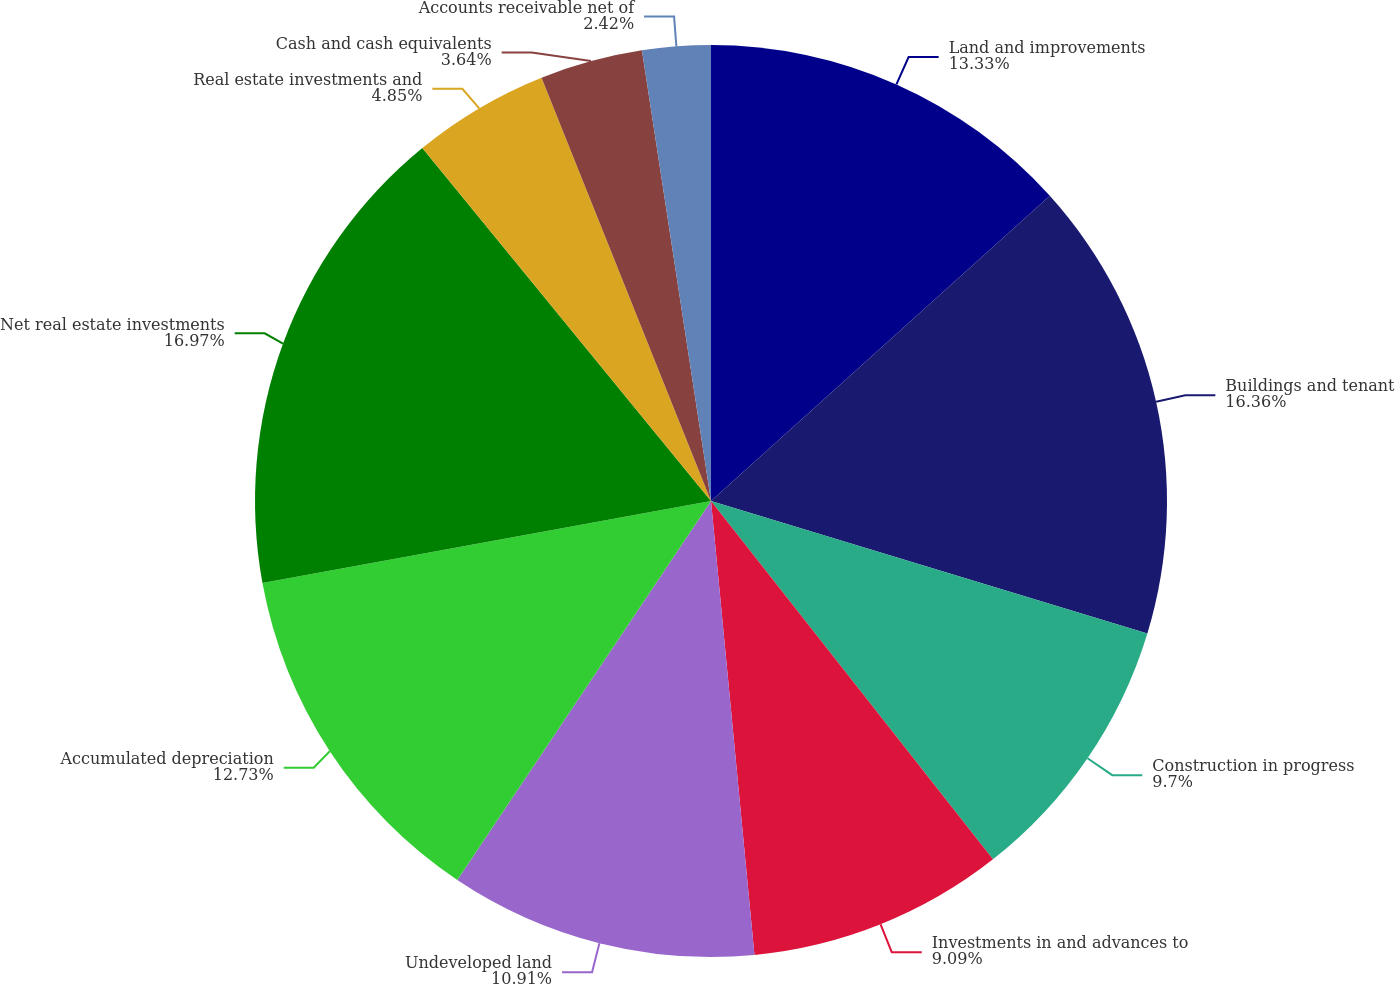Convert chart to OTSL. <chart><loc_0><loc_0><loc_500><loc_500><pie_chart><fcel>Land and improvements<fcel>Buildings and tenant<fcel>Construction in progress<fcel>Investments in and advances to<fcel>Undeveloped land<fcel>Accumulated depreciation<fcel>Net real estate investments<fcel>Real estate investments and<fcel>Cash and cash equivalents<fcel>Accounts receivable net of<nl><fcel>13.33%<fcel>16.36%<fcel>9.7%<fcel>9.09%<fcel>10.91%<fcel>12.73%<fcel>16.97%<fcel>4.85%<fcel>3.64%<fcel>2.42%<nl></chart> 